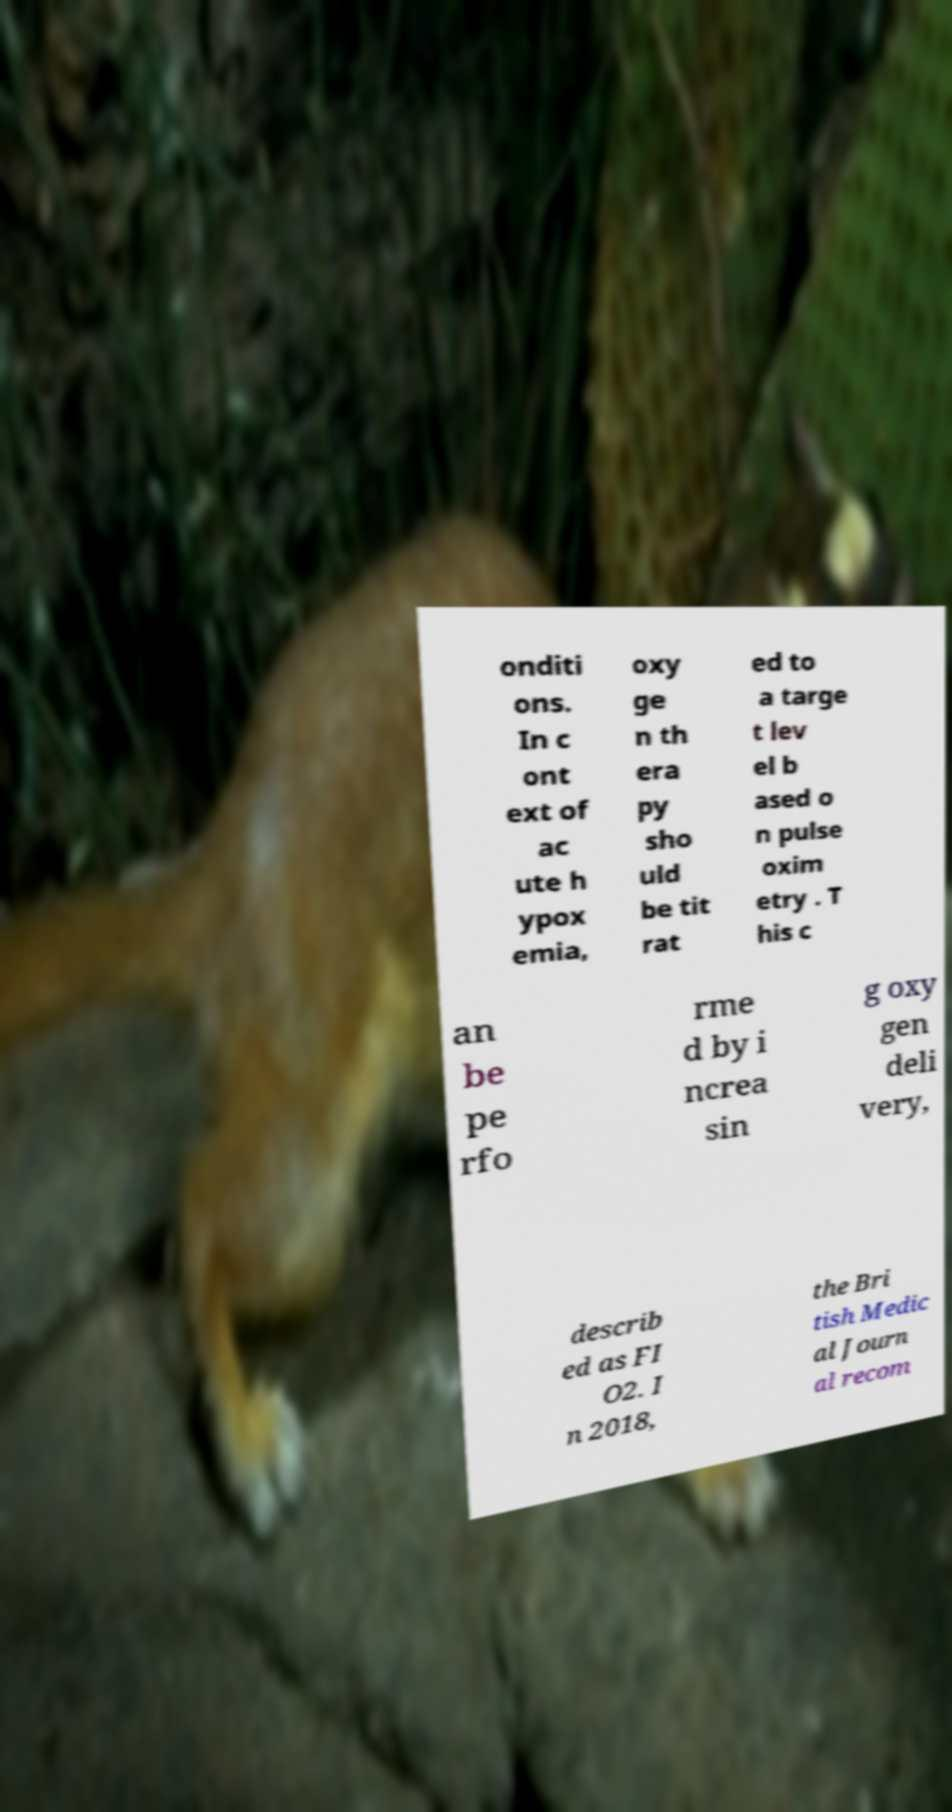Can you accurately transcribe the text from the provided image for me? onditi ons. In c ont ext of ac ute h ypox emia, oxy ge n th era py sho uld be tit rat ed to a targe t lev el b ased o n pulse oxim etry . T his c an be pe rfo rme d by i ncrea sin g oxy gen deli very, describ ed as FI O2. I n 2018, the Bri tish Medic al Journ al recom 